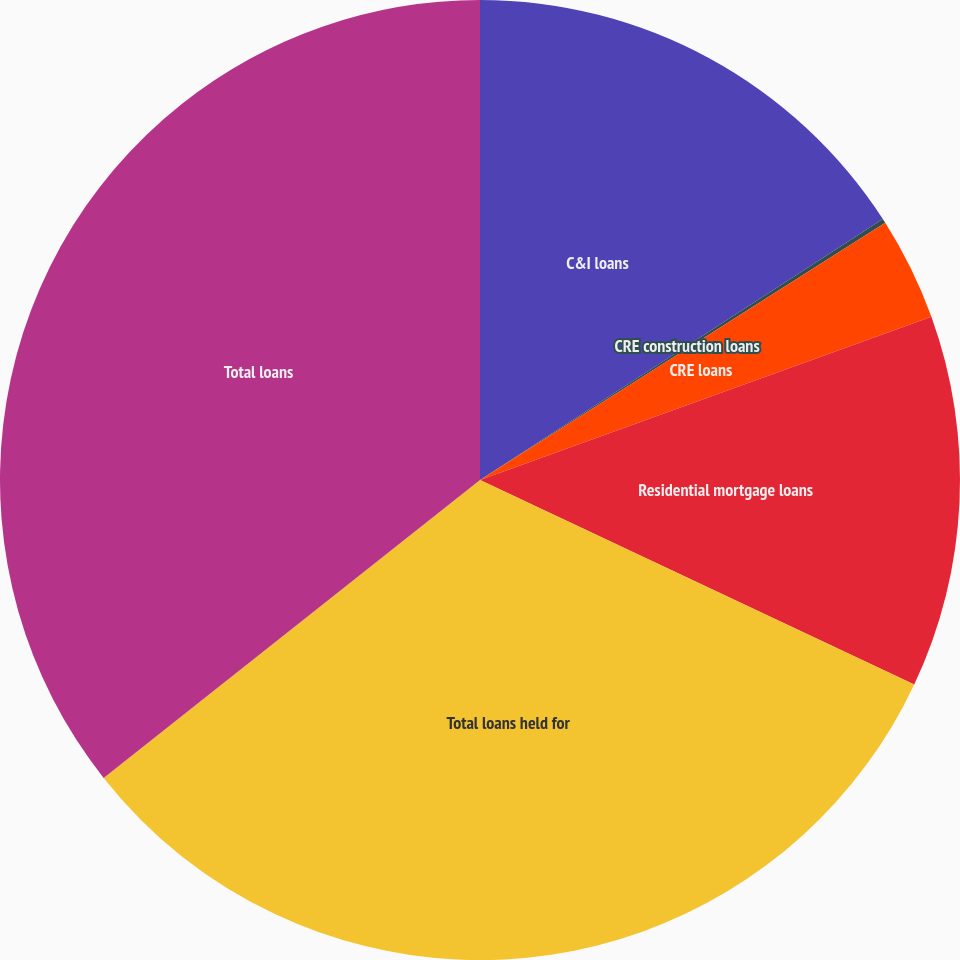Convert chart to OTSL. <chart><loc_0><loc_0><loc_500><loc_500><pie_chart><fcel>C&I loans<fcel>CRE construction loans<fcel>CRE loans<fcel>Residential mortgage loans<fcel>Total loans held for<fcel>Total loans<nl><fcel>15.85%<fcel>0.15%<fcel>3.48%<fcel>12.53%<fcel>32.34%<fcel>35.66%<nl></chart> 